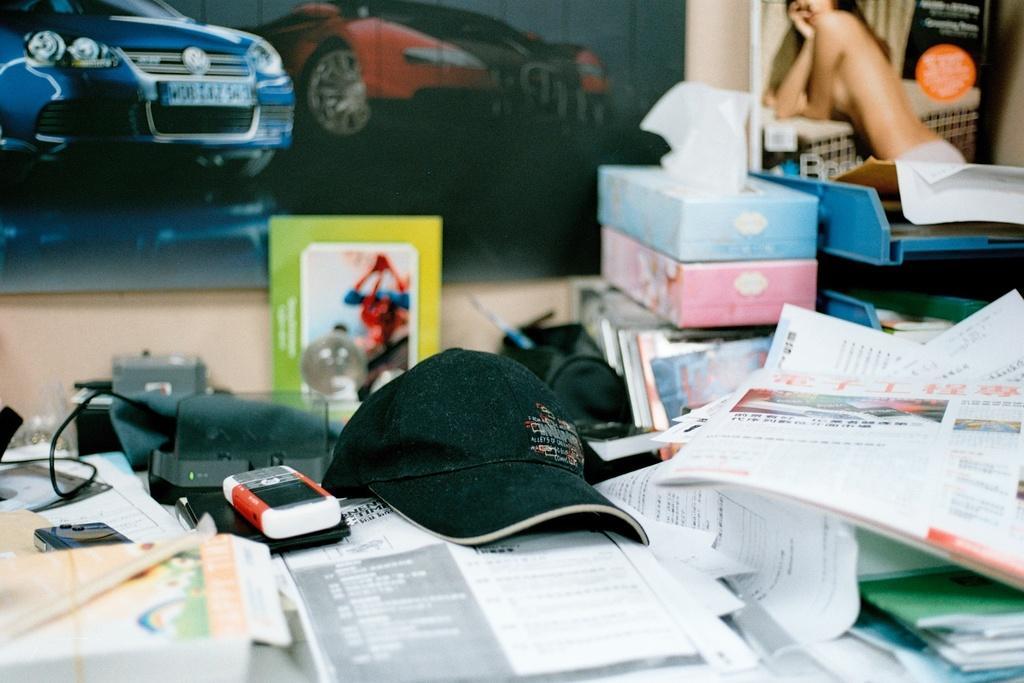In one or two sentences, can you explain what this image depicts? In this image, I can see the papers, books, cap, mobile phones, tissue paper boxes and few other objects placed here. This looks like a poster, which is attached to the wall. I think this is a magazine, which is kept on the rack. 